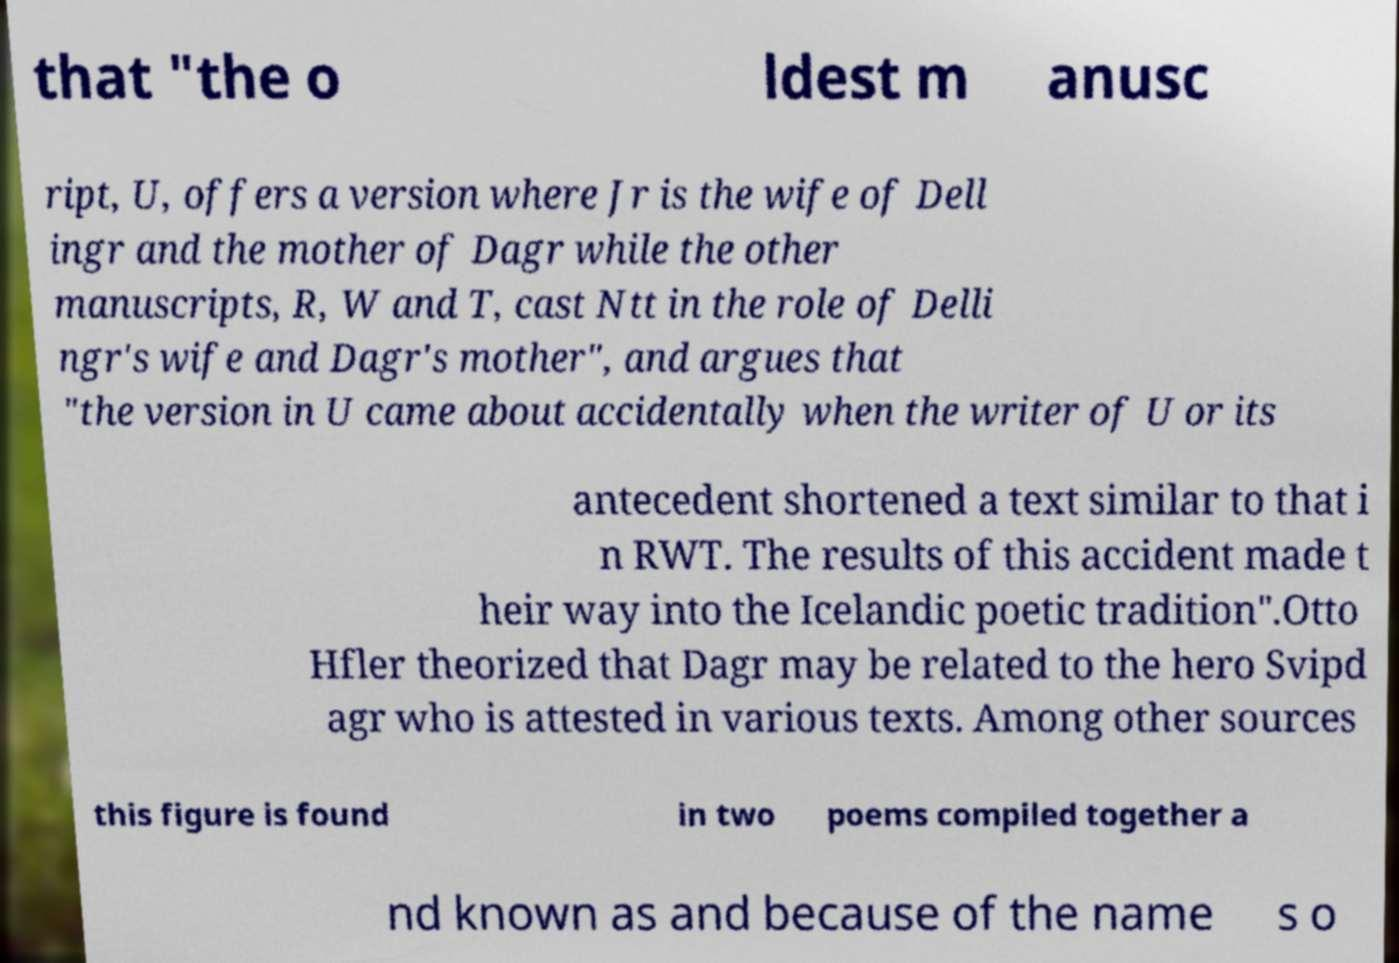What messages or text are displayed in this image? I need them in a readable, typed format. that "the o ldest m anusc ript, U, offers a version where Jr is the wife of Dell ingr and the mother of Dagr while the other manuscripts, R, W and T, cast Ntt in the role of Delli ngr's wife and Dagr's mother", and argues that "the version in U came about accidentally when the writer of U or its antecedent shortened a text similar to that i n RWT. The results of this accident made t heir way into the Icelandic poetic tradition".Otto Hfler theorized that Dagr may be related to the hero Svipd agr who is attested in various texts. Among other sources this figure is found in two poems compiled together a nd known as and because of the name s o 